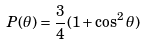Convert formula to latex. <formula><loc_0><loc_0><loc_500><loc_500>P ( \theta ) = \frac { 3 } { 4 } ( 1 + \cos ^ { 2 } \theta )</formula> 